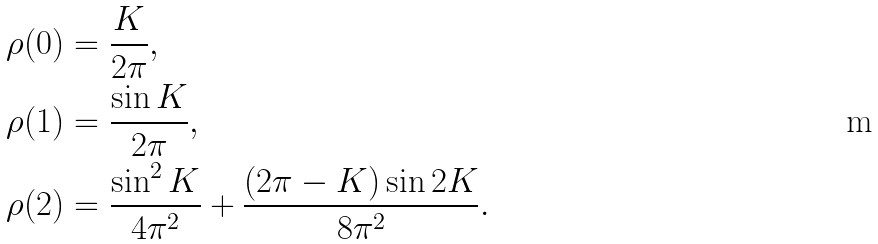<formula> <loc_0><loc_0><loc_500><loc_500>& \rho ( 0 ) = \frac { K } { 2 \pi } , \\ & \rho ( 1 ) = \frac { \sin K } { 2 \pi } , \\ & \rho ( 2 ) = \frac { \sin ^ { 2 } K } { 4 \pi ^ { 2 } } + \frac { ( 2 \pi - K ) \sin 2 K } { 8 \pi ^ { 2 } } .</formula> 